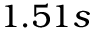<formula> <loc_0><loc_0><loc_500><loc_500>1 . 5 1 s</formula> 